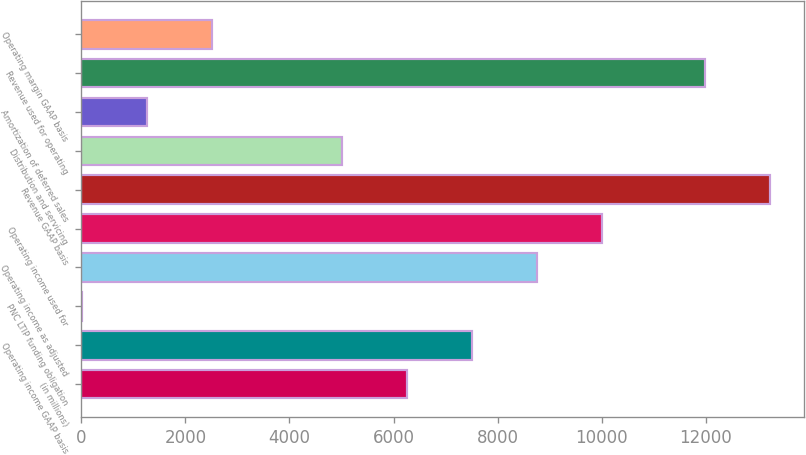<chart> <loc_0><loc_0><loc_500><loc_500><bar_chart><fcel>(in millions)<fcel>Operating income GAAP basis<fcel>PNC LTIP funding obligation<fcel>Operating income as adjusted<fcel>Operating income used for<fcel>Revenue GAAP basis<fcel>Distribution and servicing<fcel>Amortization of deferred sales<fcel>Revenue used for operating<fcel>Operating margin GAAP basis<nl><fcel>6253<fcel>7500.6<fcel>15<fcel>8748.2<fcel>9995.8<fcel>13229.6<fcel>5005.4<fcel>1262.6<fcel>11982<fcel>2510.2<nl></chart> 